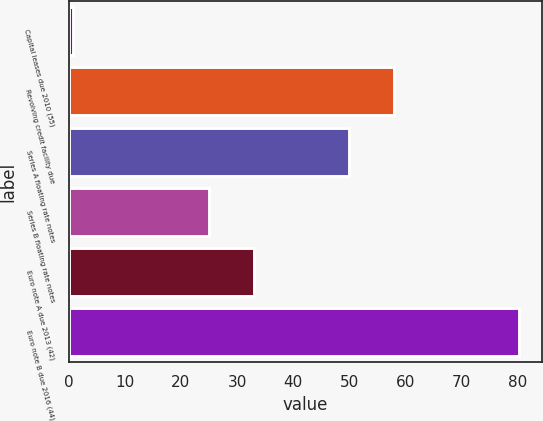Convert chart to OTSL. <chart><loc_0><loc_0><loc_500><loc_500><bar_chart><fcel>Capital leases due 2010 (55)<fcel>Revolving credit facility due<fcel>Series A floating rate notes<fcel>Series B floating rate notes<fcel>Euro note A due 2013 (42)<fcel>Euro note B due 2016 (44)<nl><fcel>0.7<fcel>57.96<fcel>50<fcel>25<fcel>32.96<fcel>80.3<nl></chart> 